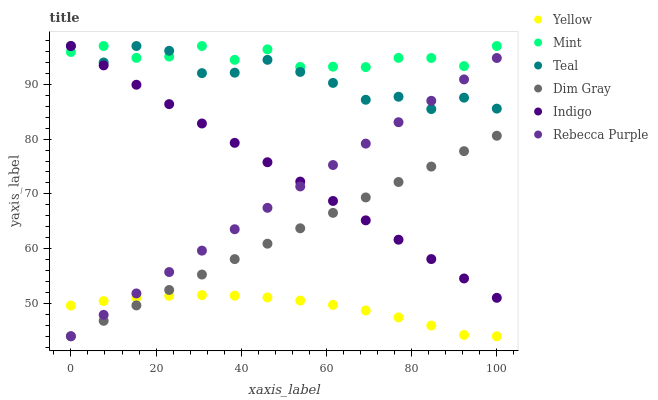Does Yellow have the minimum area under the curve?
Answer yes or no. Yes. Does Mint have the maximum area under the curve?
Answer yes or no. Yes. Does Indigo have the minimum area under the curve?
Answer yes or no. No. Does Indigo have the maximum area under the curve?
Answer yes or no. No. Is Dim Gray the smoothest?
Answer yes or no. Yes. Is Teal the roughest?
Answer yes or no. Yes. Is Indigo the smoothest?
Answer yes or no. No. Is Indigo the roughest?
Answer yes or no. No. Does Dim Gray have the lowest value?
Answer yes or no. Yes. Does Indigo have the lowest value?
Answer yes or no. No. Does Mint have the highest value?
Answer yes or no. Yes. Does Yellow have the highest value?
Answer yes or no. No. Is Dim Gray less than Teal?
Answer yes or no. Yes. Is Mint greater than Rebecca Purple?
Answer yes or no. Yes. Does Dim Gray intersect Rebecca Purple?
Answer yes or no. Yes. Is Dim Gray less than Rebecca Purple?
Answer yes or no. No. Is Dim Gray greater than Rebecca Purple?
Answer yes or no. No. Does Dim Gray intersect Teal?
Answer yes or no. No. 